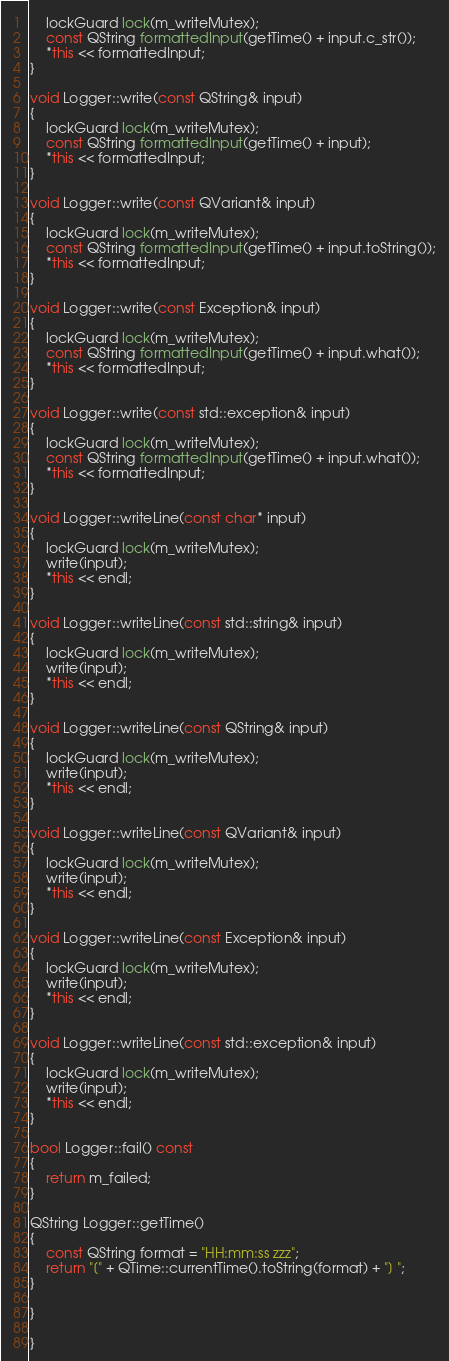Convert code to text. <code><loc_0><loc_0><loc_500><loc_500><_C++_>    lockGuard lock(m_writeMutex);
    const QString formattedInput(getTime() + input.c_str());
    *this << formattedInput;
}

void Logger::write(const QString& input)
{
    lockGuard lock(m_writeMutex);
    const QString formattedInput(getTime() + input);
    *this << formattedInput;
}

void Logger::write(const QVariant& input)
{
    lockGuard lock(m_writeMutex);
    const QString formattedInput(getTime() + input.toString());
    *this << formattedInput;
}

void Logger::write(const Exception& input)
{
    lockGuard lock(m_writeMutex);
    const QString formattedInput(getTime() + input.what());
    *this << formattedInput;
}

void Logger::write(const std::exception& input)
{
    lockGuard lock(m_writeMutex);
    const QString formattedInput(getTime() + input.what());
    *this << formattedInput;
}

void Logger::writeLine(const char* input)
{
    lockGuard lock(m_writeMutex);
    write(input);
    *this << endl;
}

void Logger::writeLine(const std::string& input)
{
    lockGuard lock(m_writeMutex);
    write(input);
    *this << endl;
}

void Logger::writeLine(const QString& input)
{
    lockGuard lock(m_writeMutex);
    write(input);
    *this << endl;
}

void Logger::writeLine(const QVariant& input)
{
    lockGuard lock(m_writeMutex);
    write(input);
    *this << endl;
}

void Logger::writeLine(const Exception& input)
{
    lockGuard lock(m_writeMutex);
    write(input);
    *this << endl;
}

void Logger::writeLine(const std::exception& input)
{
    lockGuard lock(m_writeMutex);
    write(input);
    *this << endl;
}

bool Logger::fail() const
{
    return m_failed;
}

QString Logger::getTime()
{
    const QString format = "HH:mm:ss zzz";
    return "[" + QTime::currentTime().toString(format) + "] ";
}

}

}</code> 